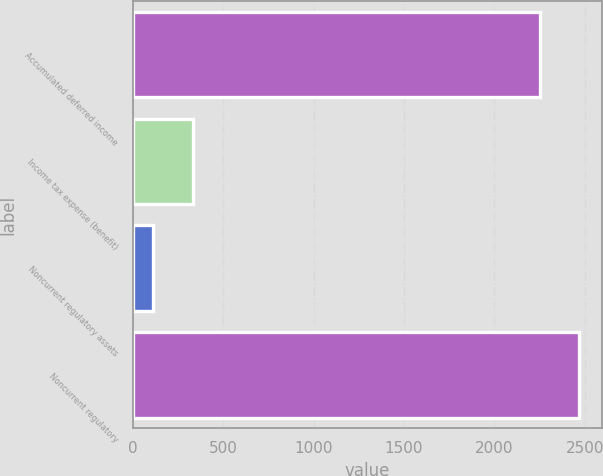<chart> <loc_0><loc_0><loc_500><loc_500><bar_chart><fcel>Accumulated deferred income<fcel>Income tax expense (benefit)<fcel>Noncurrent regulatory assets<fcel>Noncurrent regulatory<nl><fcel>2253<fcel>331.9<fcel>114<fcel>2470.9<nl></chart> 